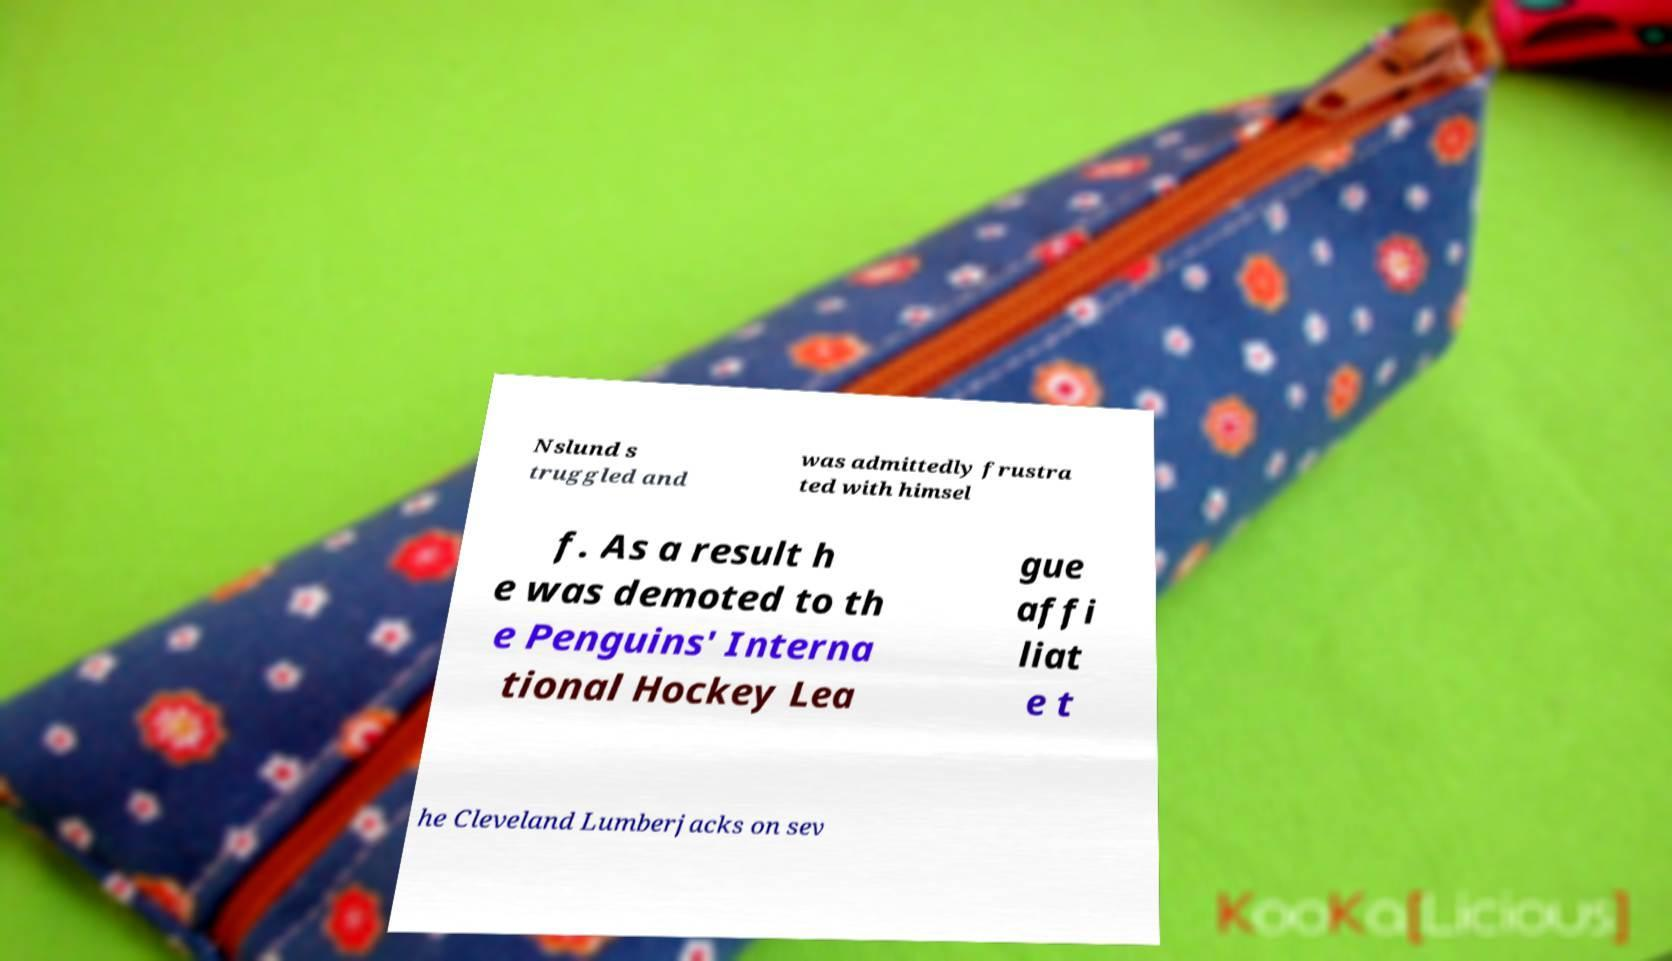Could you assist in decoding the text presented in this image and type it out clearly? Nslund s truggled and was admittedly frustra ted with himsel f. As a result h e was demoted to th e Penguins' Interna tional Hockey Lea gue affi liat e t he Cleveland Lumberjacks on sev 